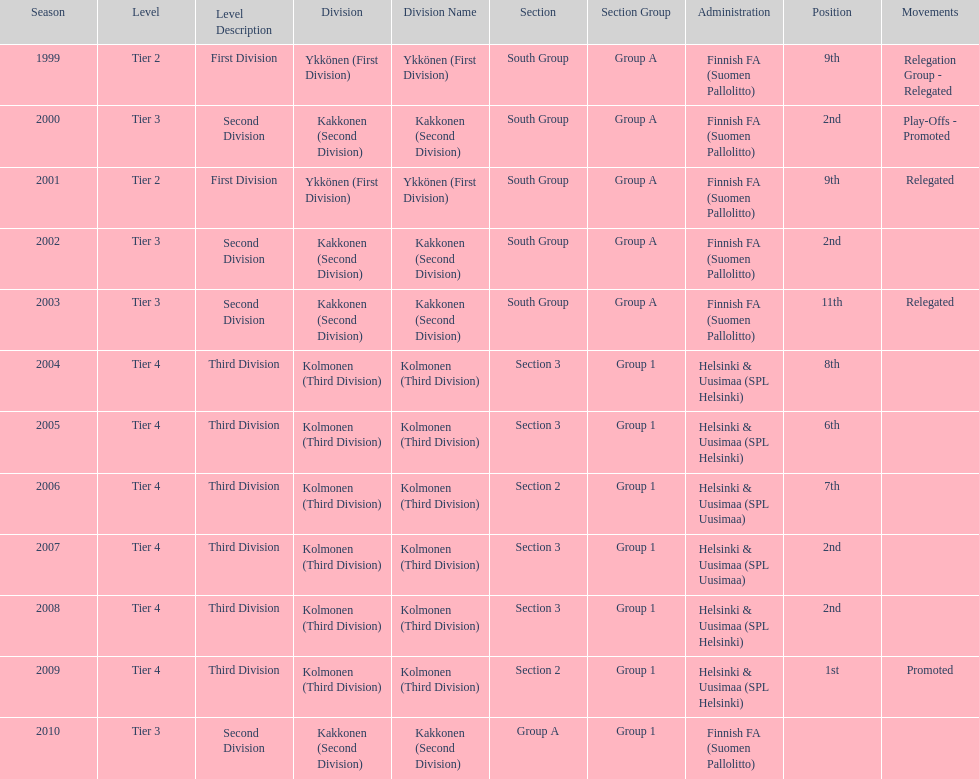What is the first tier listed? Tier 2. 